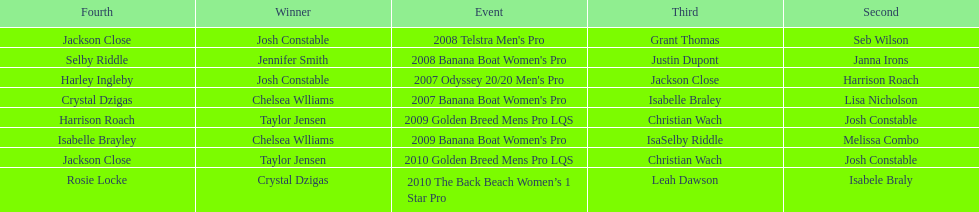How many times was josh constable second? 2. 